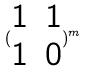<formula> <loc_0><loc_0><loc_500><loc_500>( \begin{matrix} 1 & 1 \\ 1 & 0 \end{matrix} ) ^ { m }</formula> 